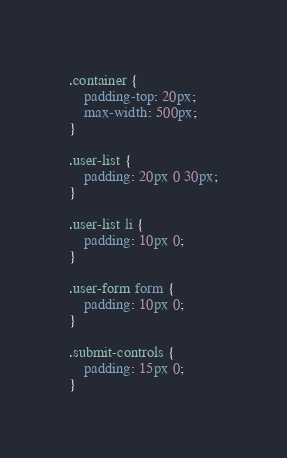Convert code to text. <code><loc_0><loc_0><loc_500><loc_500><_CSS_>.container {
    padding-top: 20px;
    max-width: 500px;
}

.user-list {
    padding: 20px 0 30px;
}

.user-list li {
    padding: 10px 0;
}

.user-form form {
    padding: 10px 0;
}

.submit-controls {
    padding: 15px 0;
}</code> 